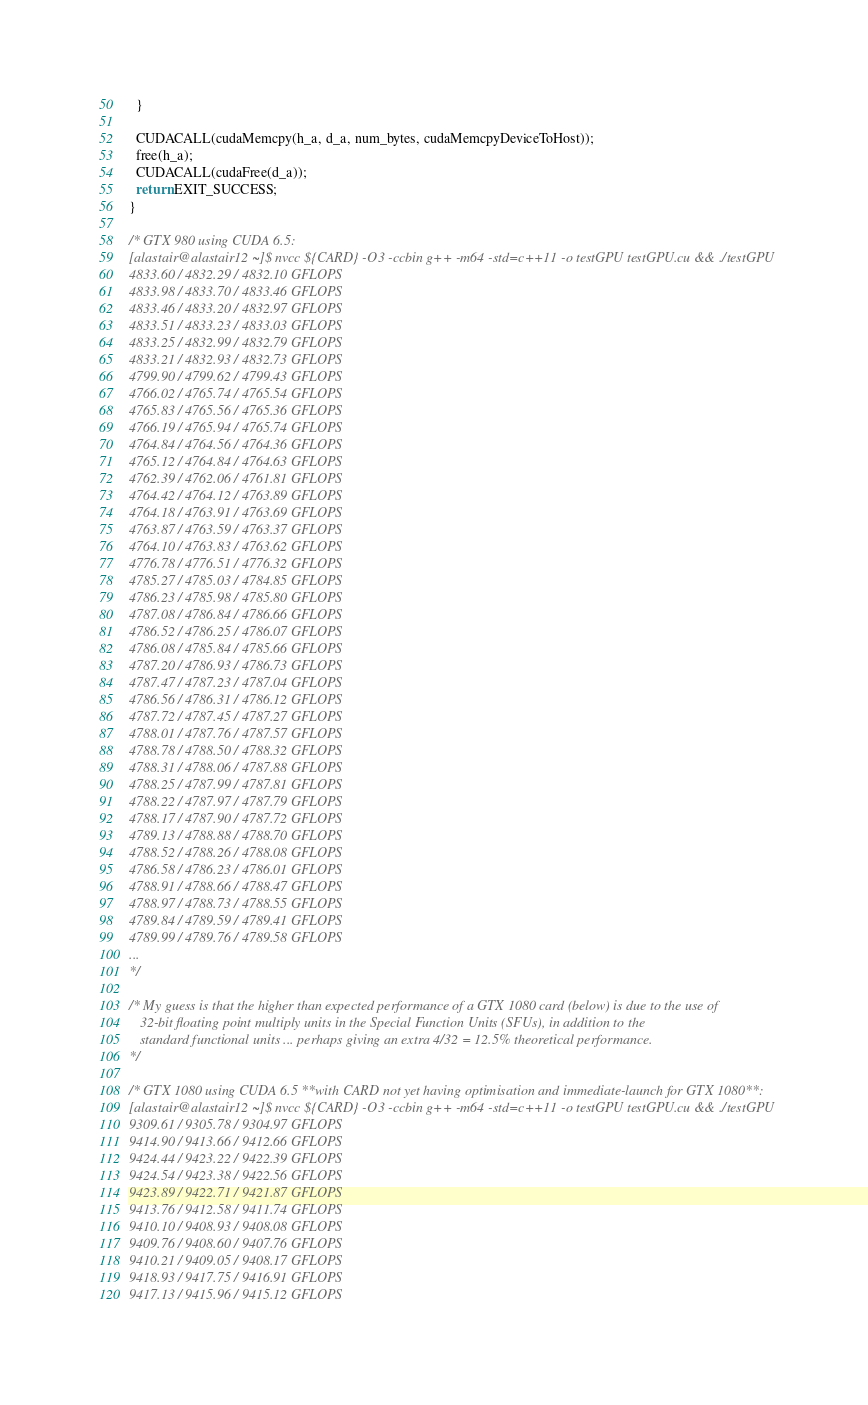<code> <loc_0><loc_0><loc_500><loc_500><_Cuda_>  }

  CUDACALL(cudaMemcpy(h_a, d_a, num_bytes, cudaMemcpyDeviceToHost));
  free(h_a);
  CUDACALL(cudaFree(d_a));
  return EXIT_SUCCESS;
}

/* GTX 980 using CUDA 6.5:
[alastair@alastair12 ~]$ nvcc ${CARD} -O3 -ccbin g++ -m64 -std=c++11 -o testGPU testGPU.cu && ./testGPU
4833.60 / 4832.29 / 4832.10 GFLOPS
4833.98 / 4833.70 / 4833.46 GFLOPS
4833.46 / 4833.20 / 4832.97 GFLOPS
4833.51 / 4833.23 / 4833.03 GFLOPS
4833.25 / 4832.99 / 4832.79 GFLOPS
4833.21 / 4832.93 / 4832.73 GFLOPS
4799.90 / 4799.62 / 4799.43 GFLOPS
4766.02 / 4765.74 / 4765.54 GFLOPS
4765.83 / 4765.56 / 4765.36 GFLOPS
4766.19 / 4765.94 / 4765.74 GFLOPS
4764.84 / 4764.56 / 4764.36 GFLOPS
4765.12 / 4764.84 / 4764.63 GFLOPS
4762.39 / 4762.06 / 4761.81 GFLOPS
4764.42 / 4764.12 / 4763.89 GFLOPS
4764.18 / 4763.91 / 4763.69 GFLOPS
4763.87 / 4763.59 / 4763.37 GFLOPS
4764.10 / 4763.83 / 4763.62 GFLOPS
4776.78 / 4776.51 / 4776.32 GFLOPS
4785.27 / 4785.03 / 4784.85 GFLOPS
4786.23 / 4785.98 / 4785.80 GFLOPS
4787.08 / 4786.84 / 4786.66 GFLOPS
4786.52 / 4786.25 / 4786.07 GFLOPS
4786.08 / 4785.84 / 4785.66 GFLOPS
4787.20 / 4786.93 / 4786.73 GFLOPS
4787.47 / 4787.23 / 4787.04 GFLOPS
4786.56 / 4786.31 / 4786.12 GFLOPS
4787.72 / 4787.45 / 4787.27 GFLOPS
4788.01 / 4787.76 / 4787.57 GFLOPS
4788.78 / 4788.50 / 4788.32 GFLOPS
4788.31 / 4788.06 / 4787.88 GFLOPS
4788.25 / 4787.99 / 4787.81 GFLOPS
4788.22 / 4787.97 / 4787.79 GFLOPS
4788.17 / 4787.90 / 4787.72 GFLOPS
4789.13 / 4788.88 / 4788.70 GFLOPS
4788.52 / 4788.26 / 4788.08 GFLOPS
4786.58 / 4786.23 / 4786.01 GFLOPS
4788.91 / 4788.66 / 4788.47 GFLOPS
4788.97 / 4788.73 / 4788.55 GFLOPS
4789.84 / 4789.59 / 4789.41 GFLOPS
4789.99 / 4789.76 / 4789.58 GFLOPS
...
*/

/* My guess is that the higher than expected performance of a GTX 1080 card (below) is due to the use of 
   32-bit floating point multiply units in the Special Function Units (SFUs), in addition to the
   standard functional units ... perhaps giving an extra 4/32 = 12.5% theoretical performance.
*/

/* GTX 1080 using CUDA 6.5 **with CARD not yet having optimisation and immediate-launch for GTX 1080**:
[alastair@alastair12 ~]$ nvcc ${CARD} -O3 -ccbin g++ -m64 -std=c++11 -o testGPU testGPU.cu && ./testGPU
9309.61 / 9305.78 / 9304.97 GFLOPS
9414.90 / 9413.66 / 9412.66 GFLOPS
9424.44 / 9423.22 / 9422.39 GFLOPS
9424.54 / 9423.38 / 9422.56 GFLOPS
9423.89 / 9422.71 / 9421.87 GFLOPS
9413.76 / 9412.58 / 9411.74 GFLOPS
9410.10 / 9408.93 / 9408.08 GFLOPS
9409.76 / 9408.60 / 9407.76 GFLOPS
9410.21 / 9409.05 / 9408.17 GFLOPS
9418.93 / 9417.75 / 9416.91 GFLOPS
9417.13 / 9415.96 / 9415.12 GFLOPS</code> 